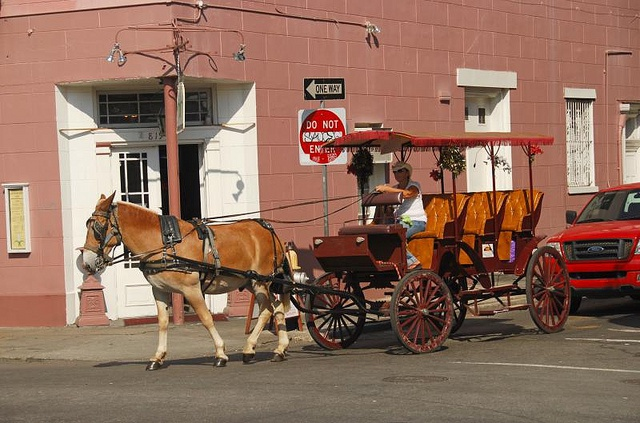Describe the objects in this image and their specific colors. I can see horse in maroon, brown, black, and gray tones, car in maroon, black, and brown tones, people in maroon, gray, and lightgray tones, and stop sign in maroon, brown, and lightgray tones in this image. 